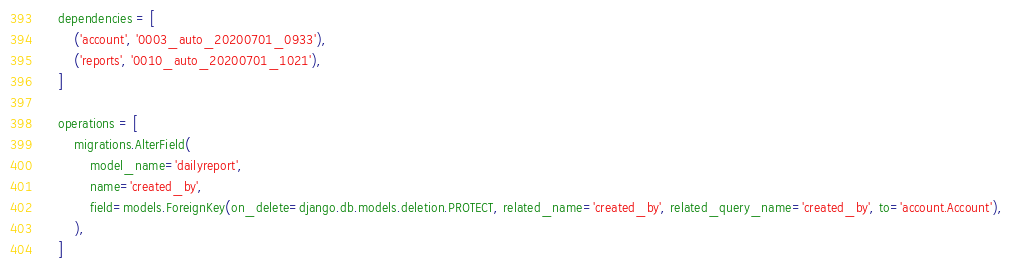<code> <loc_0><loc_0><loc_500><loc_500><_Python_>
    dependencies = [
        ('account', '0003_auto_20200701_0933'),
        ('reports', '0010_auto_20200701_1021'),
    ]

    operations = [
        migrations.AlterField(
            model_name='dailyreport',
            name='created_by',
            field=models.ForeignKey(on_delete=django.db.models.deletion.PROTECT, related_name='created_by', related_query_name='created_by', to='account.Account'),
        ),
    ]
</code> 